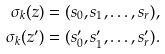Convert formula to latex. <formula><loc_0><loc_0><loc_500><loc_500>\sigma _ { k } ( z ) = ( s _ { 0 } , s _ { 1 } , \dots , s _ { r } ) , \\ \sigma _ { k } ( z ^ { \prime } ) = ( s ^ { \prime } _ { 0 } , s ^ { \prime } _ { 1 } , \dots , s ^ { \prime } _ { r } ) .</formula> 